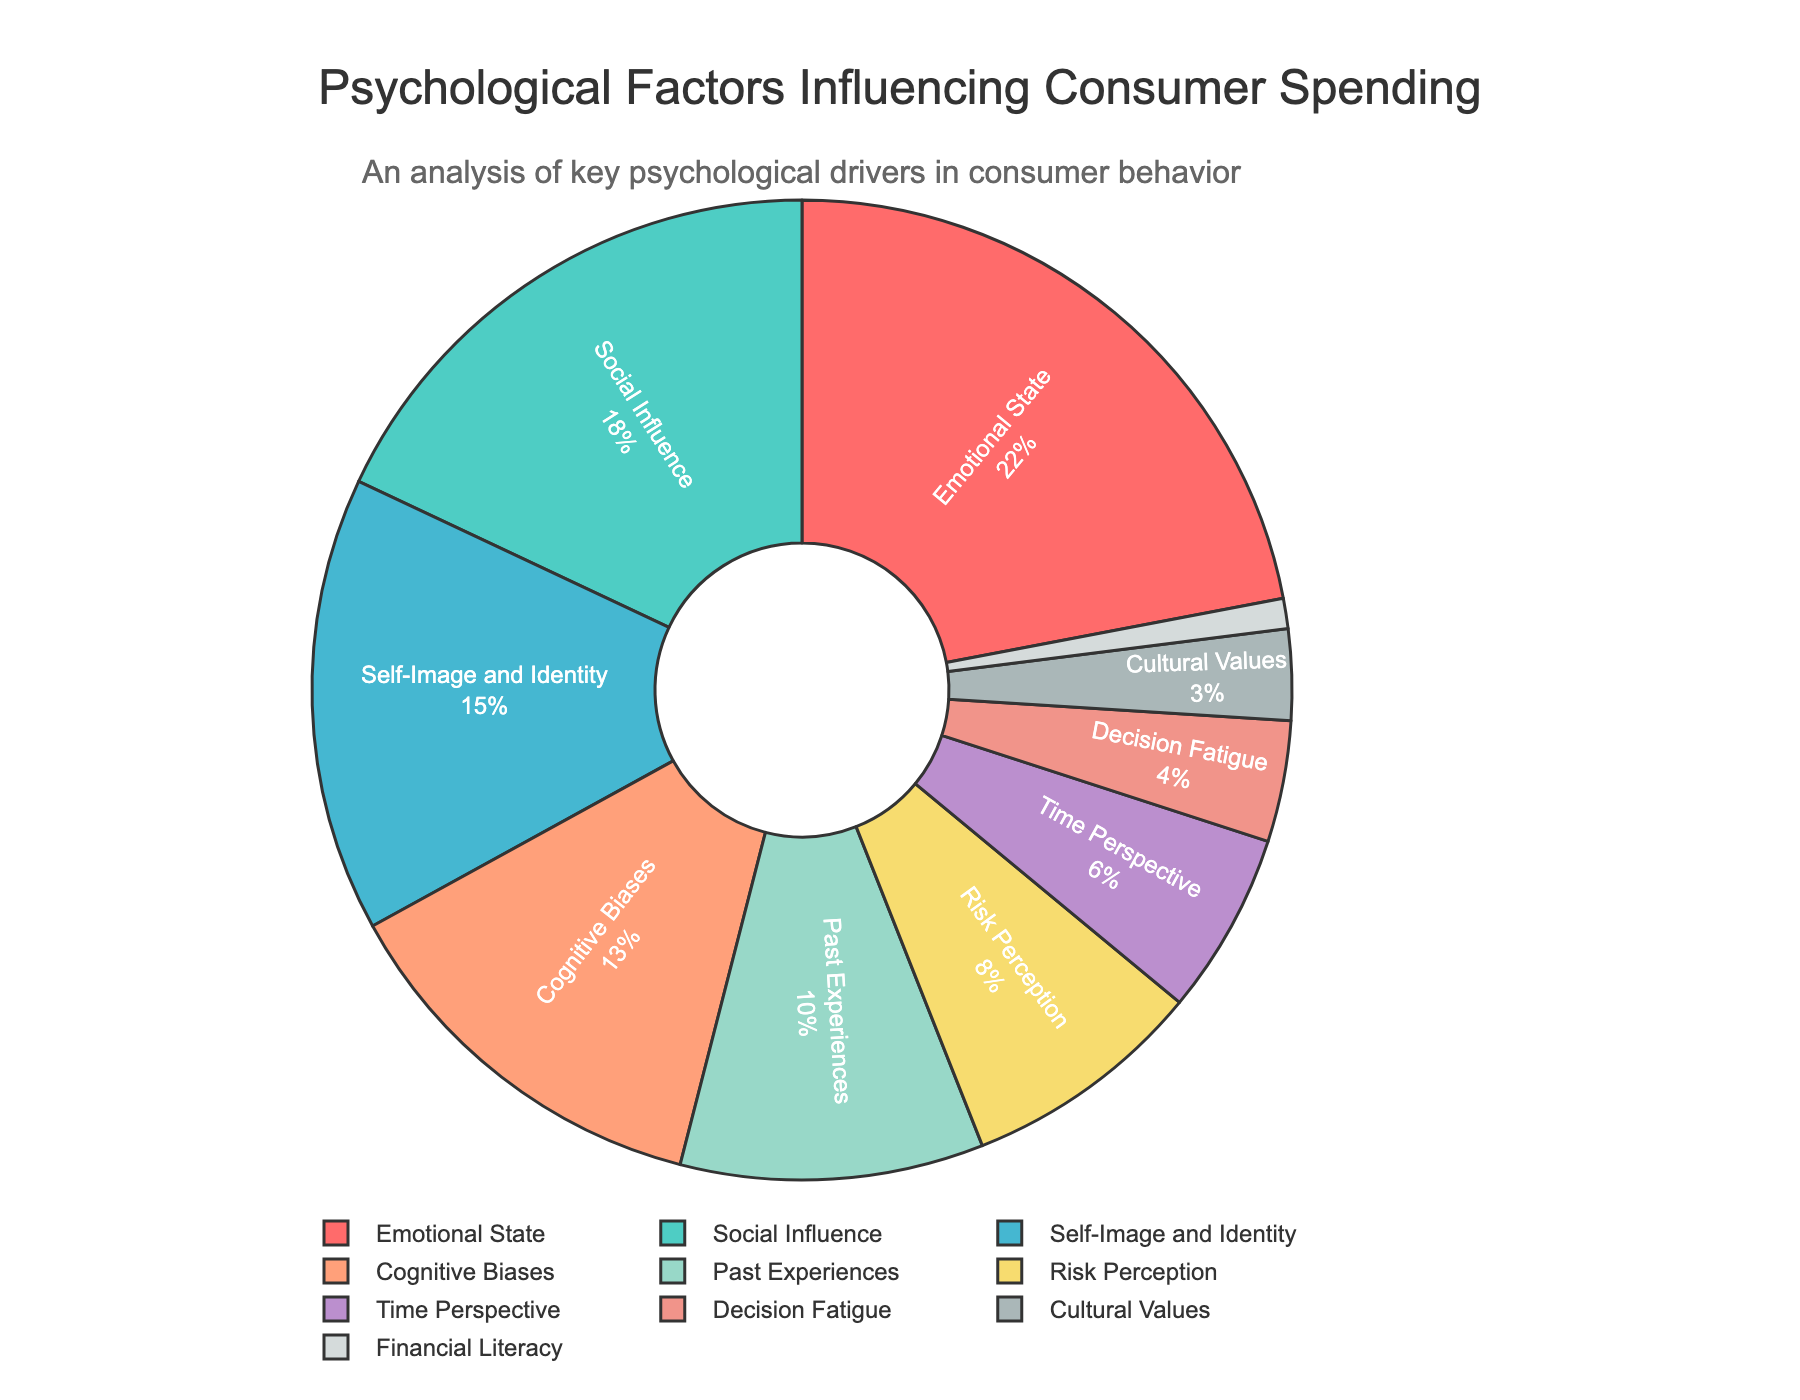What's the category with the highest percentage influence on consumer spending? The category with the highest percentage should have the largest slice in the pie chart. In this case, it’s "Emotional State".
Answer: Emotional State Which category accounts for the smallest percentage of psychological factors influencing consumer spending habits? The category with the smallest percentage should have the smallest slice in the pie chart. Here, it’s "Financial Literacy".
Answer: Financial Literacy What is the combined percentage of Social Influence and Self-Image and Identity? To find the combined percentage, simply add the percentages of Social Influence and Self-Image and Identity. 18% + 15% = 33%.
Answer: 33% How much more influential is Emotional State compared to Decision Fatigue? Subtract the percentage of Decision Fatigue from the percentage of Emotional State. 22% - 4% = 18%.
Answer: 18% What is the sum of the percentages for Cognitive Biases, Past Experiences, and Risk Perception? Add the percentages of Cognitive Biases, Past Experiences, and Risk Perception. 13% + 10% + 8% = 31%.
Answer: 31% Which categories have a combined influence greater than 30% but less than 40%? To find which categories meet this criterion, calculate the combined percentages of different combinations. Social Influence and Self-Image and Identity have a combined influence of 33%, which fits the requirement.
Answer: Social Influence, Self-Image and Identity Are Cultural Values more or less influential than Time Perspective? Compare the percentages of Cultural Values and Time Perspective. Cultural Values have 3%, and Time Perspective has 6%, so Cultural Values are less influential.
Answer: Less influential What percentage of psychological factors influencing consumer spending habits is attributed to the top three categories? Add the percentages of Emotional State, Social Influence, and Self-Image and Identity. 22% + 18% + 15% = 55%.
Answer: 55% Which category has a slice that is visually represented by the green color? The color green corresponds to Social Influence based on the palette provided in the code.
Answer: Social Influence What is the average percentage of the categories with less than 10% influence? Add the percentages of categories with less than 10% (i.e., Past Experiences, Risk Perception, Time Perspective, Decision Fatigue, Cultural Values, Financial Literacy) and then divide by the number of those categories. (10% + 8% + 6% + 4% + 3% + 1%) / 6 = 32% / 6 ≈ 5.33%.
Answer: 5.33% 